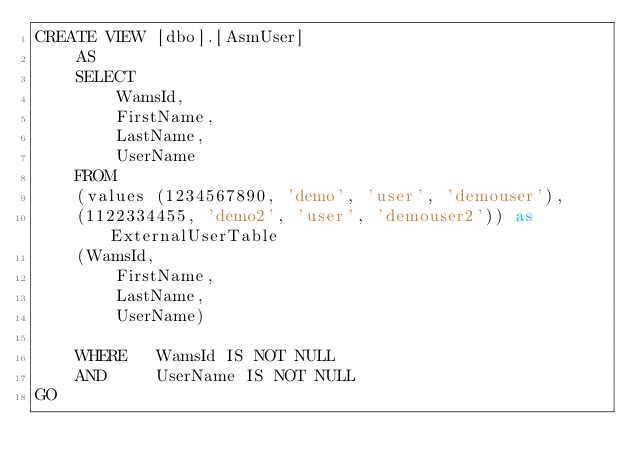<code> <loc_0><loc_0><loc_500><loc_500><_SQL_>CREATE VIEW [dbo].[AsmUser]
	AS 
	SELECT 
		WamsId,
		FirstName,
		LastName,
		UserName
	FROM  
	(values (1234567890, 'demo', 'user', 'demouser'),
	(1122334455, 'demo2', 'user', 'demouser2')) as ExternalUserTable
	(WamsId,
		FirstName,
		LastName,
		UserName)

	WHERE	WamsId IS NOT NULL
	AND		UserName IS NOT NULL
GO

</code> 